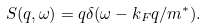<formula> <loc_0><loc_0><loc_500><loc_500>S ( q , \omega ) = q \delta ( \omega - k _ { F } q / m ^ { * } ) .</formula> 